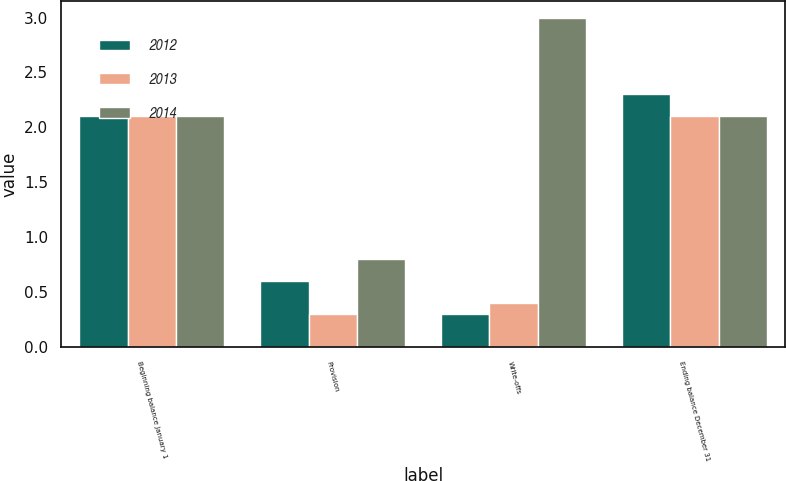Convert chart. <chart><loc_0><loc_0><loc_500><loc_500><stacked_bar_chart><ecel><fcel>Beginning balance January 1<fcel>Provision<fcel>Write-offs<fcel>Ending balance December 31<nl><fcel>2012<fcel>2.1<fcel>0.6<fcel>0.3<fcel>2.3<nl><fcel>2013<fcel>2.1<fcel>0.3<fcel>0.4<fcel>2.1<nl><fcel>2014<fcel>2.1<fcel>0.8<fcel>3<fcel>2.1<nl></chart> 